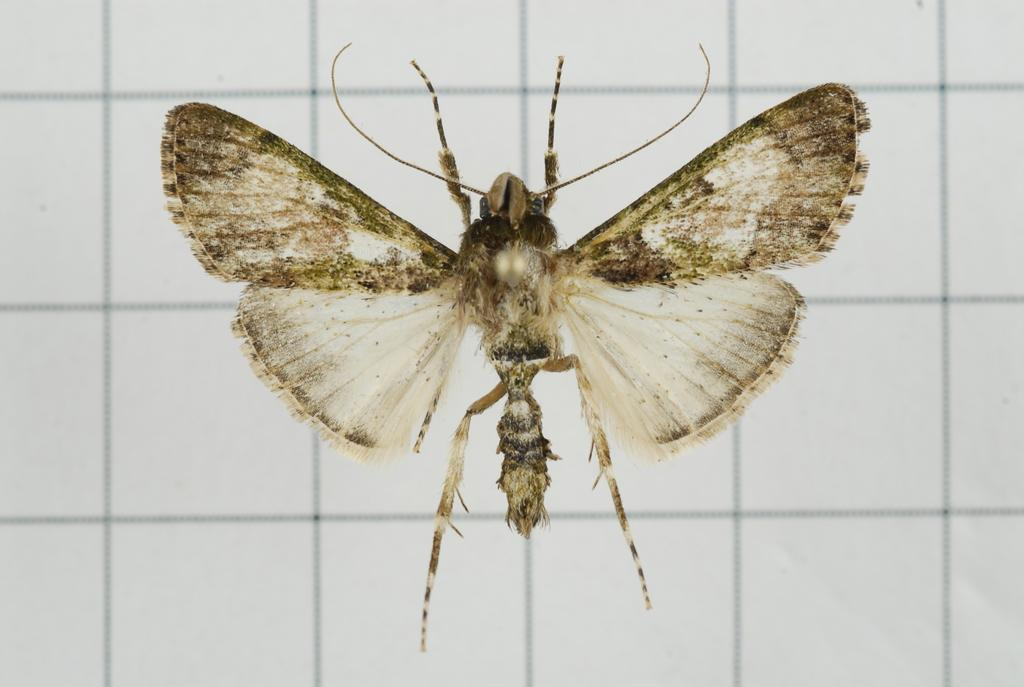What type of creature is present in the image? There is an insect in the image. Can you describe the colors of the insect? The insect has white, black, and brown colors. What is the color of the background in the image? The background of the image is white. What type of game is the insect playing in the image? There is no indication in the image that the insect is playing a game, as insects do not engage in human-like activities such as playing games. 